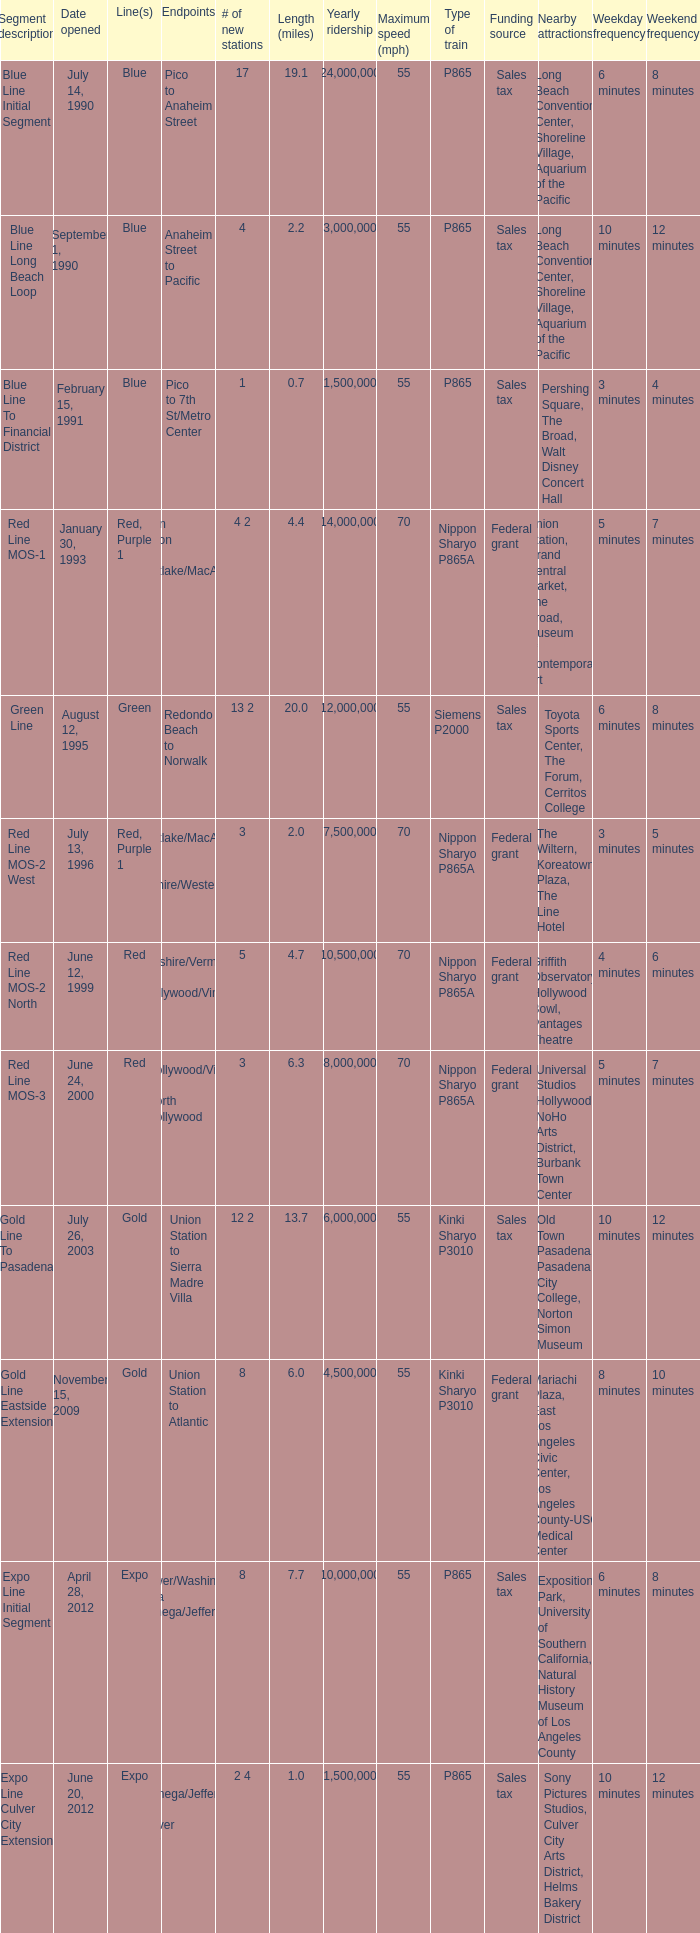How many new stations have a lenght (miles) of 6.0? 1.0. 